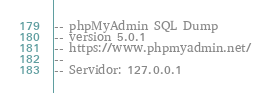Convert code to text. <code><loc_0><loc_0><loc_500><loc_500><_SQL_>-- phpMyAdmin SQL Dump
-- version 5.0.1
-- https://www.phpmyadmin.net/
--
-- Servidor: 127.0.0.1</code> 